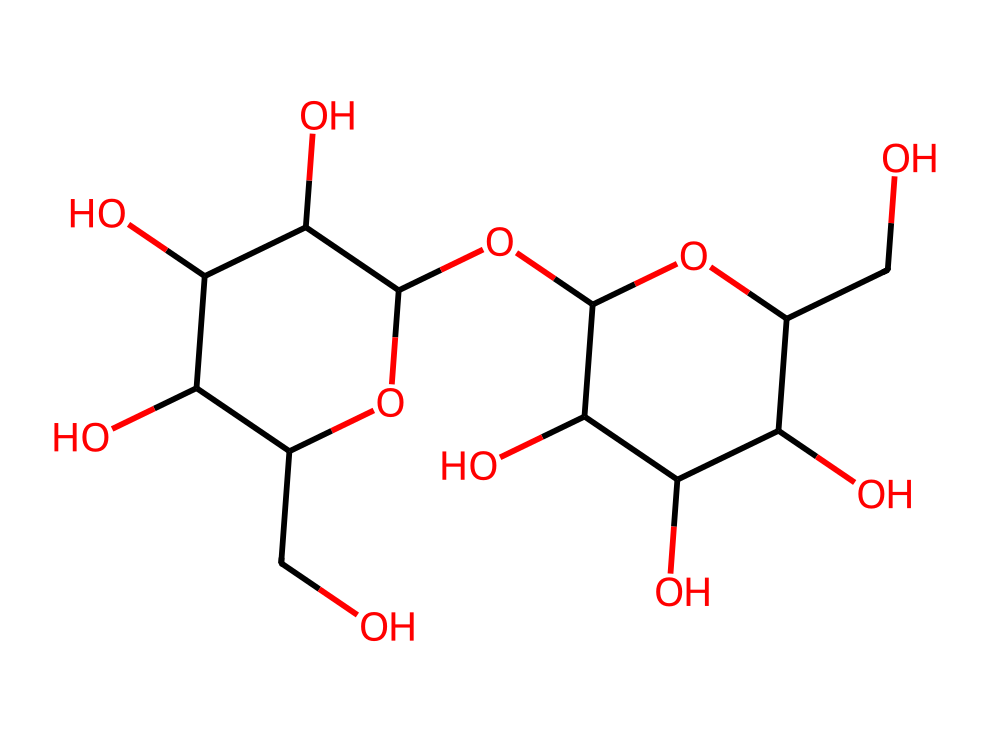What is the chemical name of this carbohydrate? The SMILES notation represents a carbohydrate that consists of two glucose units linked together, which is known as lactose.
Answer: lactose How many carbon atoms are in this molecule? By analyzing the SMILES representation, we can identify each carbon atom. There are 12 carbon atoms present in the molecule.
Answer: 12 What functional groups are present in lactose? In the structure, there are multiple hydroxyl (–OH) groups indicating it is a sugar, and also an ether bond due to the presence of an oxygen connecting two carbon chains.
Answer: hydroxyl and ether How many oxygen atoms are in the lactose structure? In the provided SMILES, each instance of 'O' indicates oxygen atoms. Counting these shows there are 6 oxygen atoms present in lactose.
Answer: 6 What type of glycosidic bond is found in lactose? Lactose consists of a β(1→4) glycosidic bond between the two glucose units, which is characteristic for disaccharides formed from glucose.
Answer: β(1→4) Does lactose have any chiral centers, and if so, how many? A chiral center is defined by a carbon atom attached to four different substituents. Analyzing the structure, there are 4 chiral centers in lactose.
Answer: 4 What is the molecular formula of lactose? Using the counts of carbon, hydrogen, and oxygen from the structure: C12, H22, O11 provides the molecular formula for lactose.
Answer: C12H22O11 